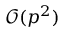Convert formula to latex. <formula><loc_0><loc_0><loc_500><loc_500>\mathcal { O } ( p ^ { 2 } )</formula> 